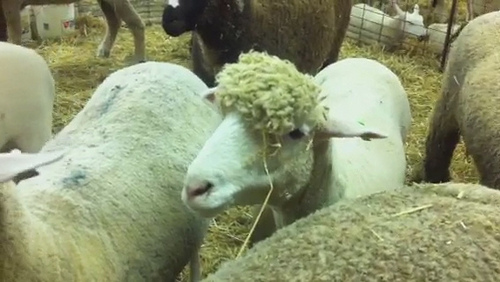Where is the sheep? The sheep is in a pen. 